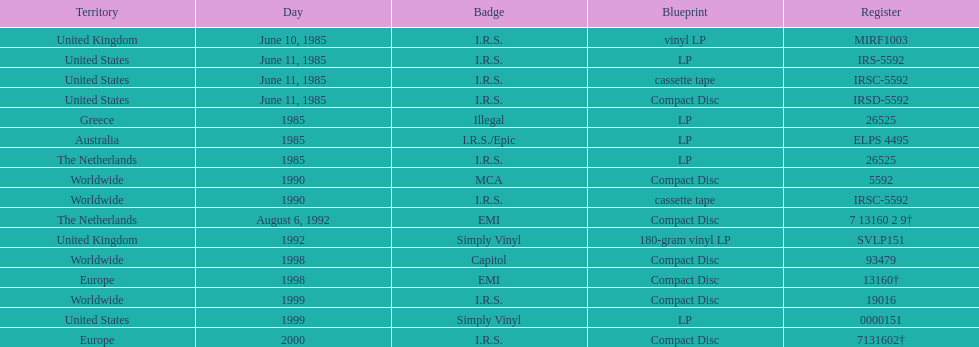Parse the table in full. {'header': ['Territory', 'Day', 'Badge', 'Blueprint', 'Register'], 'rows': [['United Kingdom', 'June 10, 1985', 'I.R.S.', 'vinyl LP', 'MIRF1003'], ['United States', 'June 11, 1985', 'I.R.S.', 'LP', 'IRS-5592'], ['United States', 'June 11, 1985', 'I.R.S.', 'cassette tape', 'IRSC-5592'], ['United States', 'June 11, 1985', 'I.R.S.', 'Compact Disc', 'IRSD-5592'], ['Greece', '1985', 'Illegal', 'LP', '26525'], ['Australia', '1985', 'I.R.S./Epic', 'LP', 'ELPS 4495'], ['The Netherlands', '1985', 'I.R.S.', 'LP', '26525'], ['Worldwide', '1990', 'MCA', 'Compact Disc', '5592'], ['Worldwide', '1990', 'I.R.S.', 'cassette tape', 'IRSC-5592'], ['The Netherlands', 'August 6, 1992', 'EMI', 'Compact Disc', '7 13160 2 9†'], ['United Kingdom', '1992', 'Simply Vinyl', '180-gram vinyl LP', 'SVLP151'], ['Worldwide', '1998', 'Capitol', 'Compact Disc', '93479'], ['Europe', '1998', 'EMI', 'Compact Disc', '13160†'], ['Worldwide', '1999', 'I.R.S.', 'Compact Disc', '19016'], ['United States', '1999', 'Simply Vinyl', 'LP', '0000151'], ['Europe', '2000', 'I.R.S.', 'Compact Disc', '7131602†']]} Name at least two labels that released the group's albums. I.R.S., Illegal. 